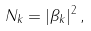<formula> <loc_0><loc_0><loc_500><loc_500>N _ { k } = | \beta _ { k } | ^ { 2 } \, ,</formula> 